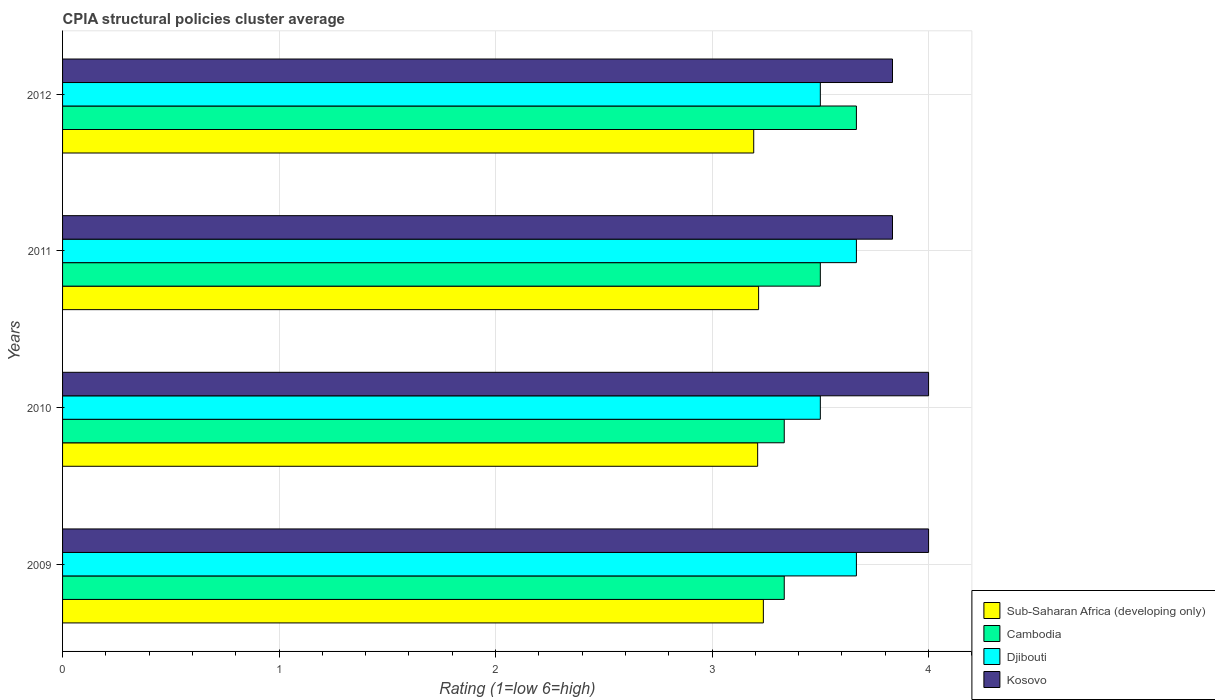How many bars are there on the 1st tick from the bottom?
Make the answer very short. 4. What is the label of the 3rd group of bars from the top?
Keep it short and to the point. 2010. In how many cases, is the number of bars for a given year not equal to the number of legend labels?
Keep it short and to the point. 0. What is the CPIA rating in Djibouti in 2011?
Your response must be concise. 3.67. Across all years, what is the maximum CPIA rating in Cambodia?
Your response must be concise. 3.67. Across all years, what is the minimum CPIA rating in Djibouti?
Ensure brevity in your answer.  3.5. In which year was the CPIA rating in Cambodia maximum?
Give a very brief answer. 2012. What is the total CPIA rating in Kosovo in the graph?
Offer a very short reply. 15.67. What is the difference between the CPIA rating in Sub-Saharan Africa (developing only) in 2010 and that in 2012?
Provide a succinct answer. 0.02. What is the average CPIA rating in Djibouti per year?
Provide a succinct answer. 3.58. In the year 2009, what is the difference between the CPIA rating in Kosovo and CPIA rating in Sub-Saharan Africa (developing only)?
Offer a terse response. 0.76. In how many years, is the CPIA rating in Kosovo greater than 2.2 ?
Keep it short and to the point. 4. What is the ratio of the CPIA rating in Djibouti in 2010 to that in 2011?
Your answer should be compact. 0.95. Is the difference between the CPIA rating in Kosovo in 2010 and 2012 greater than the difference between the CPIA rating in Sub-Saharan Africa (developing only) in 2010 and 2012?
Your answer should be compact. Yes. What is the difference between the highest and the second highest CPIA rating in Cambodia?
Ensure brevity in your answer.  0.17. What is the difference between the highest and the lowest CPIA rating in Cambodia?
Provide a short and direct response. 0.33. Is the sum of the CPIA rating in Sub-Saharan Africa (developing only) in 2009 and 2011 greater than the maximum CPIA rating in Djibouti across all years?
Keep it short and to the point. Yes. What does the 4th bar from the top in 2012 represents?
Make the answer very short. Sub-Saharan Africa (developing only). What does the 1st bar from the bottom in 2012 represents?
Offer a terse response. Sub-Saharan Africa (developing only). Is it the case that in every year, the sum of the CPIA rating in Sub-Saharan Africa (developing only) and CPIA rating in Kosovo is greater than the CPIA rating in Djibouti?
Provide a short and direct response. Yes. How many bars are there?
Offer a very short reply. 16. How many years are there in the graph?
Ensure brevity in your answer.  4. Are the values on the major ticks of X-axis written in scientific E-notation?
Provide a short and direct response. No. Does the graph contain any zero values?
Give a very brief answer. No. Does the graph contain grids?
Provide a short and direct response. Yes. How many legend labels are there?
Offer a very short reply. 4. How are the legend labels stacked?
Your response must be concise. Vertical. What is the title of the graph?
Make the answer very short. CPIA structural policies cluster average. Does "Cameroon" appear as one of the legend labels in the graph?
Your answer should be very brief. No. What is the Rating (1=low 6=high) of Sub-Saharan Africa (developing only) in 2009?
Ensure brevity in your answer.  3.24. What is the Rating (1=low 6=high) in Cambodia in 2009?
Your answer should be compact. 3.33. What is the Rating (1=low 6=high) in Djibouti in 2009?
Provide a succinct answer. 3.67. What is the Rating (1=low 6=high) of Kosovo in 2009?
Your answer should be compact. 4. What is the Rating (1=low 6=high) in Sub-Saharan Africa (developing only) in 2010?
Keep it short and to the point. 3.21. What is the Rating (1=low 6=high) of Cambodia in 2010?
Ensure brevity in your answer.  3.33. What is the Rating (1=low 6=high) of Sub-Saharan Africa (developing only) in 2011?
Offer a terse response. 3.21. What is the Rating (1=low 6=high) of Cambodia in 2011?
Make the answer very short. 3.5. What is the Rating (1=low 6=high) in Djibouti in 2011?
Keep it short and to the point. 3.67. What is the Rating (1=low 6=high) of Kosovo in 2011?
Provide a succinct answer. 3.83. What is the Rating (1=low 6=high) of Sub-Saharan Africa (developing only) in 2012?
Your answer should be very brief. 3.19. What is the Rating (1=low 6=high) of Cambodia in 2012?
Your response must be concise. 3.67. What is the Rating (1=low 6=high) of Djibouti in 2012?
Your answer should be compact. 3.5. What is the Rating (1=low 6=high) in Kosovo in 2012?
Offer a very short reply. 3.83. Across all years, what is the maximum Rating (1=low 6=high) in Sub-Saharan Africa (developing only)?
Your answer should be very brief. 3.24. Across all years, what is the maximum Rating (1=low 6=high) of Cambodia?
Your answer should be very brief. 3.67. Across all years, what is the maximum Rating (1=low 6=high) in Djibouti?
Make the answer very short. 3.67. Across all years, what is the maximum Rating (1=low 6=high) of Kosovo?
Keep it short and to the point. 4. Across all years, what is the minimum Rating (1=low 6=high) of Sub-Saharan Africa (developing only)?
Offer a terse response. 3.19. Across all years, what is the minimum Rating (1=low 6=high) in Cambodia?
Provide a short and direct response. 3.33. Across all years, what is the minimum Rating (1=low 6=high) of Djibouti?
Keep it short and to the point. 3.5. Across all years, what is the minimum Rating (1=low 6=high) of Kosovo?
Give a very brief answer. 3.83. What is the total Rating (1=low 6=high) in Sub-Saharan Africa (developing only) in the graph?
Make the answer very short. 12.85. What is the total Rating (1=low 6=high) in Cambodia in the graph?
Your response must be concise. 13.83. What is the total Rating (1=low 6=high) of Djibouti in the graph?
Give a very brief answer. 14.33. What is the total Rating (1=low 6=high) in Kosovo in the graph?
Give a very brief answer. 15.67. What is the difference between the Rating (1=low 6=high) of Sub-Saharan Africa (developing only) in 2009 and that in 2010?
Your answer should be compact. 0.03. What is the difference between the Rating (1=low 6=high) of Djibouti in 2009 and that in 2010?
Keep it short and to the point. 0.17. What is the difference between the Rating (1=low 6=high) in Sub-Saharan Africa (developing only) in 2009 and that in 2011?
Your answer should be very brief. 0.02. What is the difference between the Rating (1=low 6=high) in Cambodia in 2009 and that in 2011?
Provide a short and direct response. -0.17. What is the difference between the Rating (1=low 6=high) in Kosovo in 2009 and that in 2011?
Ensure brevity in your answer.  0.17. What is the difference between the Rating (1=low 6=high) of Sub-Saharan Africa (developing only) in 2009 and that in 2012?
Ensure brevity in your answer.  0.04. What is the difference between the Rating (1=low 6=high) of Kosovo in 2009 and that in 2012?
Your answer should be very brief. 0.17. What is the difference between the Rating (1=low 6=high) of Sub-Saharan Africa (developing only) in 2010 and that in 2011?
Offer a very short reply. -0. What is the difference between the Rating (1=low 6=high) of Cambodia in 2010 and that in 2011?
Provide a succinct answer. -0.17. What is the difference between the Rating (1=low 6=high) in Kosovo in 2010 and that in 2011?
Your response must be concise. 0.17. What is the difference between the Rating (1=low 6=high) in Sub-Saharan Africa (developing only) in 2010 and that in 2012?
Your answer should be very brief. 0.02. What is the difference between the Rating (1=low 6=high) in Sub-Saharan Africa (developing only) in 2011 and that in 2012?
Provide a succinct answer. 0.02. What is the difference between the Rating (1=low 6=high) in Cambodia in 2011 and that in 2012?
Your answer should be compact. -0.17. What is the difference between the Rating (1=low 6=high) of Sub-Saharan Africa (developing only) in 2009 and the Rating (1=low 6=high) of Cambodia in 2010?
Your response must be concise. -0.1. What is the difference between the Rating (1=low 6=high) of Sub-Saharan Africa (developing only) in 2009 and the Rating (1=low 6=high) of Djibouti in 2010?
Provide a short and direct response. -0.26. What is the difference between the Rating (1=low 6=high) of Sub-Saharan Africa (developing only) in 2009 and the Rating (1=low 6=high) of Kosovo in 2010?
Provide a short and direct response. -0.76. What is the difference between the Rating (1=low 6=high) of Cambodia in 2009 and the Rating (1=low 6=high) of Djibouti in 2010?
Your response must be concise. -0.17. What is the difference between the Rating (1=low 6=high) in Sub-Saharan Africa (developing only) in 2009 and the Rating (1=low 6=high) in Cambodia in 2011?
Offer a terse response. -0.26. What is the difference between the Rating (1=low 6=high) in Sub-Saharan Africa (developing only) in 2009 and the Rating (1=low 6=high) in Djibouti in 2011?
Provide a succinct answer. -0.43. What is the difference between the Rating (1=low 6=high) in Sub-Saharan Africa (developing only) in 2009 and the Rating (1=low 6=high) in Kosovo in 2011?
Ensure brevity in your answer.  -0.6. What is the difference between the Rating (1=low 6=high) in Cambodia in 2009 and the Rating (1=low 6=high) in Djibouti in 2011?
Keep it short and to the point. -0.33. What is the difference between the Rating (1=low 6=high) in Cambodia in 2009 and the Rating (1=low 6=high) in Kosovo in 2011?
Ensure brevity in your answer.  -0.5. What is the difference between the Rating (1=low 6=high) in Sub-Saharan Africa (developing only) in 2009 and the Rating (1=low 6=high) in Cambodia in 2012?
Provide a succinct answer. -0.43. What is the difference between the Rating (1=low 6=high) of Sub-Saharan Africa (developing only) in 2009 and the Rating (1=low 6=high) of Djibouti in 2012?
Offer a very short reply. -0.26. What is the difference between the Rating (1=low 6=high) in Sub-Saharan Africa (developing only) in 2009 and the Rating (1=low 6=high) in Kosovo in 2012?
Provide a succinct answer. -0.6. What is the difference between the Rating (1=low 6=high) in Djibouti in 2009 and the Rating (1=low 6=high) in Kosovo in 2012?
Provide a short and direct response. -0.17. What is the difference between the Rating (1=low 6=high) in Sub-Saharan Africa (developing only) in 2010 and the Rating (1=low 6=high) in Cambodia in 2011?
Offer a terse response. -0.29. What is the difference between the Rating (1=low 6=high) in Sub-Saharan Africa (developing only) in 2010 and the Rating (1=low 6=high) in Djibouti in 2011?
Provide a succinct answer. -0.46. What is the difference between the Rating (1=low 6=high) in Sub-Saharan Africa (developing only) in 2010 and the Rating (1=low 6=high) in Kosovo in 2011?
Make the answer very short. -0.62. What is the difference between the Rating (1=low 6=high) of Cambodia in 2010 and the Rating (1=low 6=high) of Kosovo in 2011?
Keep it short and to the point. -0.5. What is the difference between the Rating (1=low 6=high) of Sub-Saharan Africa (developing only) in 2010 and the Rating (1=low 6=high) of Cambodia in 2012?
Provide a succinct answer. -0.46. What is the difference between the Rating (1=low 6=high) of Sub-Saharan Africa (developing only) in 2010 and the Rating (1=low 6=high) of Djibouti in 2012?
Your answer should be compact. -0.29. What is the difference between the Rating (1=low 6=high) of Sub-Saharan Africa (developing only) in 2010 and the Rating (1=low 6=high) of Kosovo in 2012?
Ensure brevity in your answer.  -0.62. What is the difference between the Rating (1=low 6=high) of Sub-Saharan Africa (developing only) in 2011 and the Rating (1=low 6=high) of Cambodia in 2012?
Offer a terse response. -0.45. What is the difference between the Rating (1=low 6=high) in Sub-Saharan Africa (developing only) in 2011 and the Rating (1=low 6=high) in Djibouti in 2012?
Provide a short and direct response. -0.29. What is the difference between the Rating (1=low 6=high) of Sub-Saharan Africa (developing only) in 2011 and the Rating (1=low 6=high) of Kosovo in 2012?
Your response must be concise. -0.62. What is the difference between the Rating (1=low 6=high) in Djibouti in 2011 and the Rating (1=low 6=high) in Kosovo in 2012?
Make the answer very short. -0.17. What is the average Rating (1=low 6=high) in Sub-Saharan Africa (developing only) per year?
Offer a very short reply. 3.21. What is the average Rating (1=low 6=high) in Cambodia per year?
Make the answer very short. 3.46. What is the average Rating (1=low 6=high) in Djibouti per year?
Your response must be concise. 3.58. What is the average Rating (1=low 6=high) in Kosovo per year?
Give a very brief answer. 3.92. In the year 2009, what is the difference between the Rating (1=low 6=high) in Sub-Saharan Africa (developing only) and Rating (1=low 6=high) in Cambodia?
Give a very brief answer. -0.1. In the year 2009, what is the difference between the Rating (1=low 6=high) in Sub-Saharan Africa (developing only) and Rating (1=low 6=high) in Djibouti?
Keep it short and to the point. -0.43. In the year 2009, what is the difference between the Rating (1=low 6=high) of Sub-Saharan Africa (developing only) and Rating (1=low 6=high) of Kosovo?
Your answer should be compact. -0.76. In the year 2009, what is the difference between the Rating (1=low 6=high) in Cambodia and Rating (1=low 6=high) in Djibouti?
Your answer should be very brief. -0.33. In the year 2009, what is the difference between the Rating (1=low 6=high) of Cambodia and Rating (1=low 6=high) of Kosovo?
Give a very brief answer. -0.67. In the year 2010, what is the difference between the Rating (1=low 6=high) in Sub-Saharan Africa (developing only) and Rating (1=low 6=high) in Cambodia?
Give a very brief answer. -0.12. In the year 2010, what is the difference between the Rating (1=low 6=high) in Sub-Saharan Africa (developing only) and Rating (1=low 6=high) in Djibouti?
Provide a short and direct response. -0.29. In the year 2010, what is the difference between the Rating (1=low 6=high) of Sub-Saharan Africa (developing only) and Rating (1=low 6=high) of Kosovo?
Keep it short and to the point. -0.79. In the year 2010, what is the difference between the Rating (1=low 6=high) of Djibouti and Rating (1=low 6=high) of Kosovo?
Provide a short and direct response. -0.5. In the year 2011, what is the difference between the Rating (1=low 6=high) of Sub-Saharan Africa (developing only) and Rating (1=low 6=high) of Cambodia?
Offer a terse response. -0.29. In the year 2011, what is the difference between the Rating (1=low 6=high) in Sub-Saharan Africa (developing only) and Rating (1=low 6=high) in Djibouti?
Your answer should be very brief. -0.45. In the year 2011, what is the difference between the Rating (1=low 6=high) of Sub-Saharan Africa (developing only) and Rating (1=low 6=high) of Kosovo?
Keep it short and to the point. -0.62. In the year 2011, what is the difference between the Rating (1=low 6=high) of Cambodia and Rating (1=low 6=high) of Djibouti?
Provide a succinct answer. -0.17. In the year 2011, what is the difference between the Rating (1=low 6=high) in Djibouti and Rating (1=low 6=high) in Kosovo?
Your answer should be compact. -0.17. In the year 2012, what is the difference between the Rating (1=low 6=high) in Sub-Saharan Africa (developing only) and Rating (1=low 6=high) in Cambodia?
Keep it short and to the point. -0.47. In the year 2012, what is the difference between the Rating (1=low 6=high) in Sub-Saharan Africa (developing only) and Rating (1=low 6=high) in Djibouti?
Offer a very short reply. -0.31. In the year 2012, what is the difference between the Rating (1=low 6=high) of Sub-Saharan Africa (developing only) and Rating (1=low 6=high) of Kosovo?
Offer a terse response. -0.64. In the year 2012, what is the difference between the Rating (1=low 6=high) of Cambodia and Rating (1=low 6=high) of Djibouti?
Offer a very short reply. 0.17. In the year 2012, what is the difference between the Rating (1=low 6=high) in Cambodia and Rating (1=low 6=high) in Kosovo?
Provide a short and direct response. -0.17. What is the ratio of the Rating (1=low 6=high) in Sub-Saharan Africa (developing only) in 2009 to that in 2010?
Give a very brief answer. 1.01. What is the ratio of the Rating (1=low 6=high) in Djibouti in 2009 to that in 2010?
Keep it short and to the point. 1.05. What is the ratio of the Rating (1=low 6=high) of Sub-Saharan Africa (developing only) in 2009 to that in 2011?
Keep it short and to the point. 1.01. What is the ratio of the Rating (1=low 6=high) of Kosovo in 2009 to that in 2011?
Offer a terse response. 1.04. What is the ratio of the Rating (1=low 6=high) in Djibouti in 2009 to that in 2012?
Your answer should be very brief. 1.05. What is the ratio of the Rating (1=low 6=high) in Kosovo in 2009 to that in 2012?
Provide a succinct answer. 1.04. What is the ratio of the Rating (1=low 6=high) of Sub-Saharan Africa (developing only) in 2010 to that in 2011?
Offer a very short reply. 1. What is the ratio of the Rating (1=low 6=high) in Djibouti in 2010 to that in 2011?
Keep it short and to the point. 0.95. What is the ratio of the Rating (1=low 6=high) of Kosovo in 2010 to that in 2011?
Ensure brevity in your answer.  1.04. What is the ratio of the Rating (1=low 6=high) of Sub-Saharan Africa (developing only) in 2010 to that in 2012?
Provide a succinct answer. 1.01. What is the ratio of the Rating (1=low 6=high) in Kosovo in 2010 to that in 2012?
Offer a terse response. 1.04. What is the ratio of the Rating (1=low 6=high) in Sub-Saharan Africa (developing only) in 2011 to that in 2012?
Keep it short and to the point. 1.01. What is the ratio of the Rating (1=low 6=high) of Cambodia in 2011 to that in 2012?
Provide a short and direct response. 0.95. What is the ratio of the Rating (1=low 6=high) in Djibouti in 2011 to that in 2012?
Provide a succinct answer. 1.05. What is the difference between the highest and the second highest Rating (1=low 6=high) of Sub-Saharan Africa (developing only)?
Offer a terse response. 0.02. What is the difference between the highest and the second highest Rating (1=low 6=high) of Djibouti?
Provide a short and direct response. 0. What is the difference between the highest and the second highest Rating (1=low 6=high) in Kosovo?
Your response must be concise. 0. What is the difference between the highest and the lowest Rating (1=low 6=high) of Sub-Saharan Africa (developing only)?
Make the answer very short. 0.04. What is the difference between the highest and the lowest Rating (1=low 6=high) in Djibouti?
Ensure brevity in your answer.  0.17. What is the difference between the highest and the lowest Rating (1=low 6=high) in Kosovo?
Make the answer very short. 0.17. 